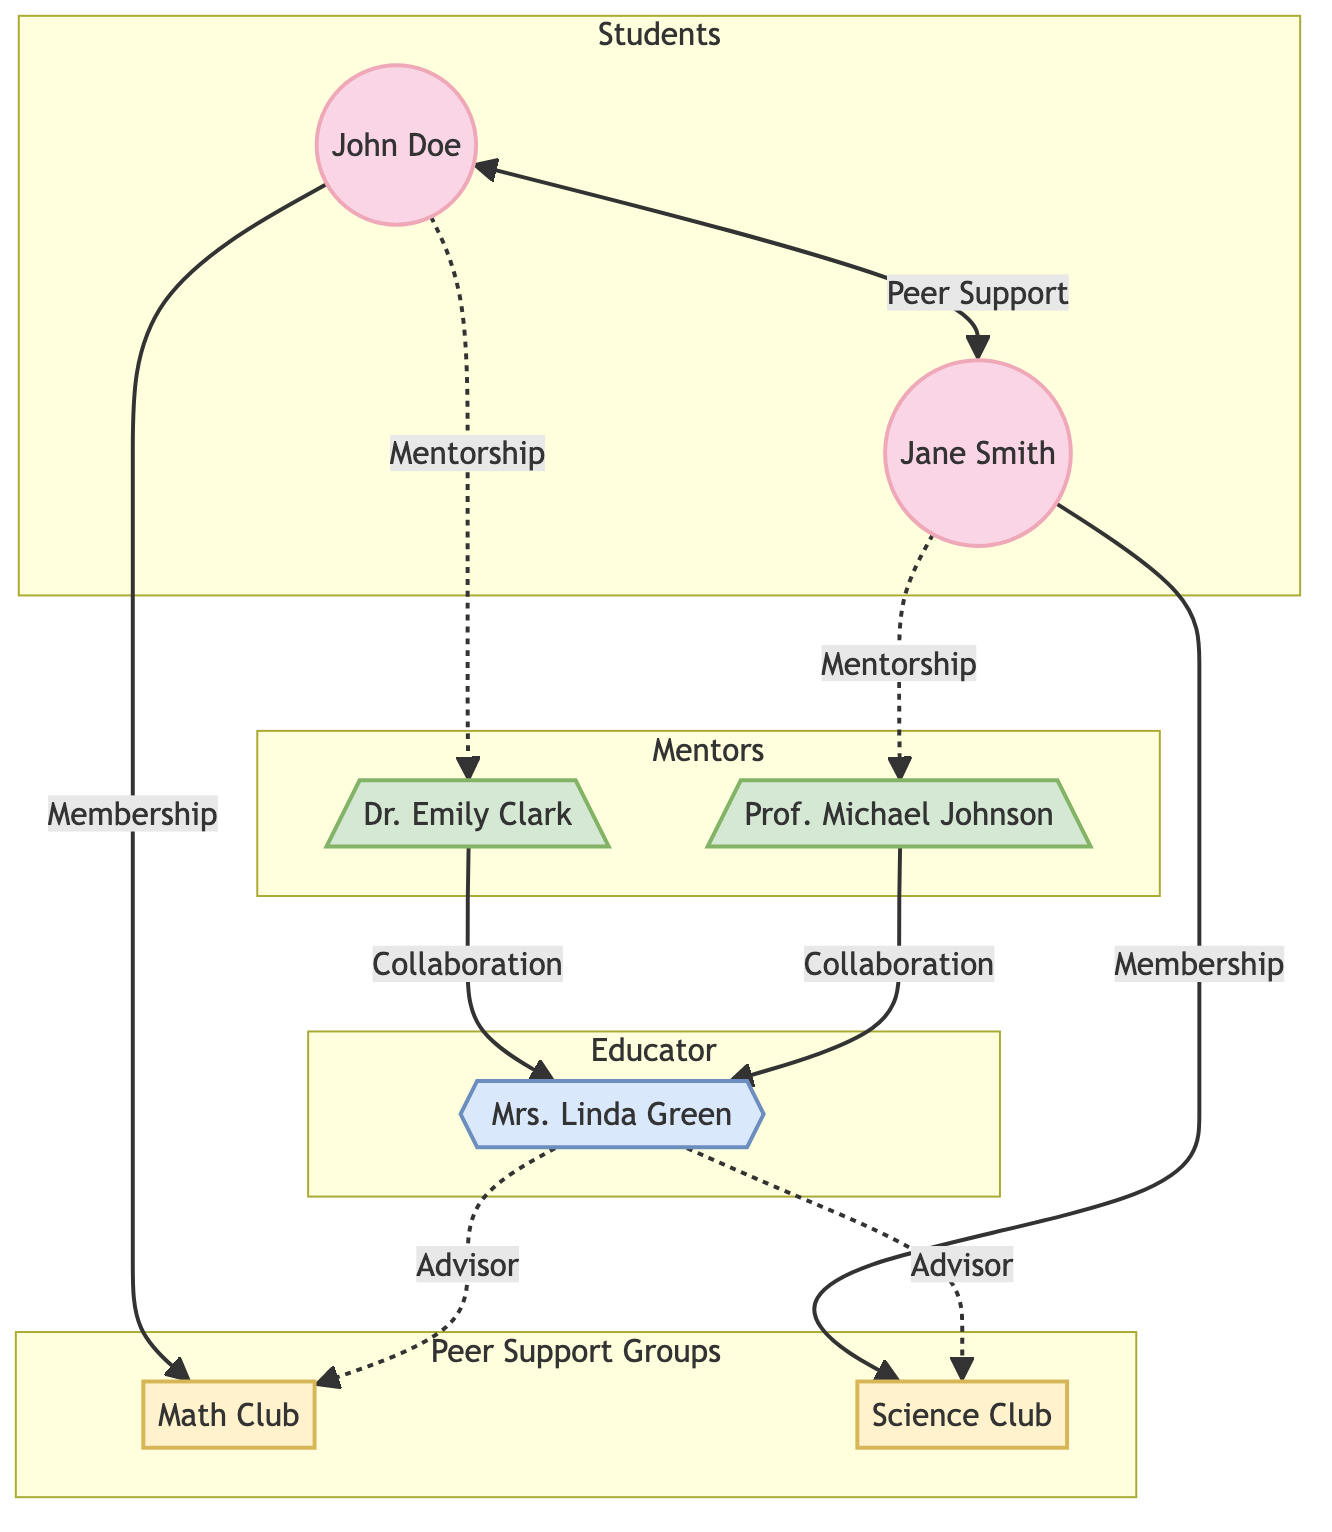What is the total number of nodes in the diagram? The diagram contains nodes for two students, two mentors, one educator, and two peer support groups. Adding these up gives a total of 2 (students) + 2 (mentors) + 1 (educator) + 2 (peer support groups) = 7 nodes.
Answer: 7 Who is the mentor for John Doe? The diagram shows that John Doe is connected to Dr. Emily Clark, indicating that she is his mentor.
Answer: Dr. Emily Clark What type of relationship exists between Jane Smith and Prof. Michael Johnson? The diagram indicates that Jane Smith has a mentorship relationship with Prof. Michael Johnson, as represented by the edge labeled "Mentorship" from Jane to Prof. Michael.
Answer: Mentorship How many peer support groups are linked to the educator? By examining the edges connected to Mrs. Linda Green (the educator), it can be seen that she is connected to both peer support groups (Math Club and Science Club), leading to a total of 2.
Answer: 2 Which students are part of the same peer support system? The diagram shows a connection labeled "Peer Support" between John Doe and Jane Smith, indicating they are part of the same peer support system.
Answer: John Doe and Jane Smith Who collaborates with whom among the mentors and the educator? The diagram reveals that both mentors, Dr. Emily Clark and Prof. Michael Johnson, collaborate with Mrs. Linda Green, which is represented by two edges labeled "Collaboration."
Answer: Dr. Emily Clark and Prof. Michael Johnson What is the relationship type between John Doe and the Math Club? The diagram shows a direct relationship labeled "Membership" from John Doe to the Math Club, indicating his active role in the club.
Answer: Membership Which peer support group is associated with Jane Smith? The diagram indicates that Jane Smith is connected to the Science Club through a "Membership," so the answer is that she is associated with the Science Club.
Answer: Science Club How many unique types of relationships are present in this diagram? The relationships represented in the diagram include "Mentorship," "Collaboration," "Membership," "Peer Support," and "Advisor." Counting these, there are 5 unique types of relationships in total.
Answer: 5 